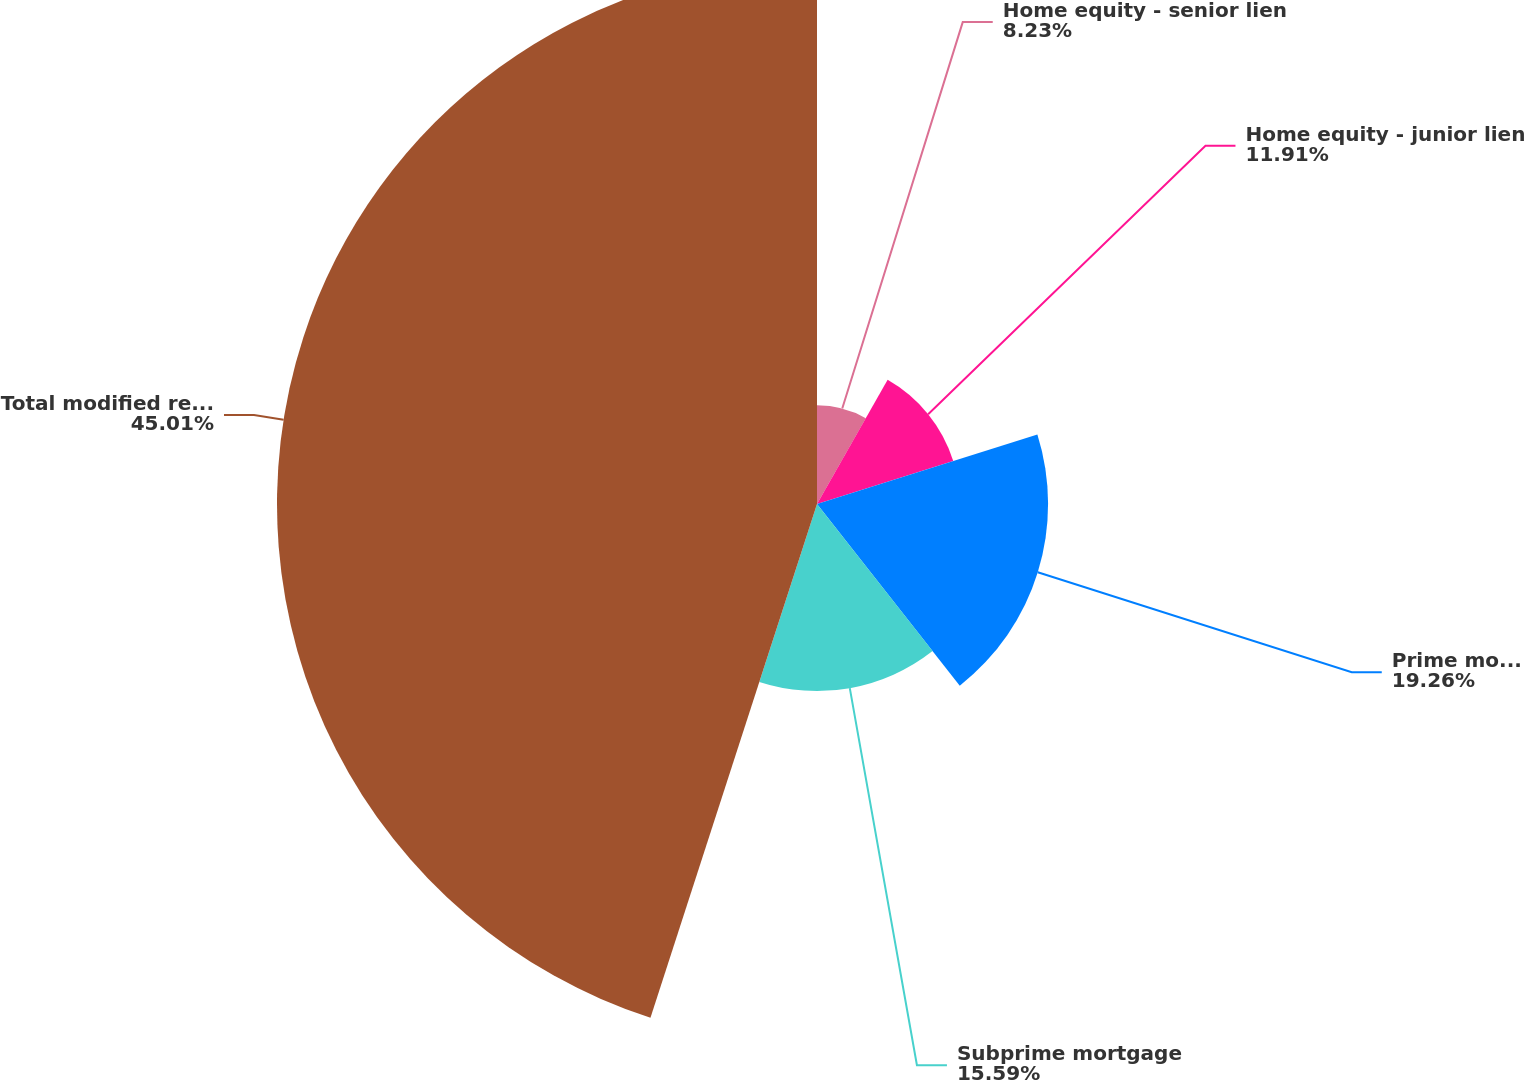Convert chart to OTSL. <chart><loc_0><loc_0><loc_500><loc_500><pie_chart><fcel>Home equity - senior lien<fcel>Home equity - junior lien<fcel>Prime mortgage including<fcel>Subprime mortgage<fcel>Total modified residential<nl><fcel>8.23%<fcel>11.91%<fcel>19.26%<fcel>15.59%<fcel>45.01%<nl></chart> 